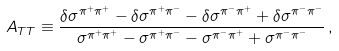Convert formula to latex. <formula><loc_0><loc_0><loc_500><loc_500>A _ { T T } \equiv \frac { \delta \sigma ^ { \pi ^ { + } \pi ^ { + } } - \delta \sigma ^ { \pi ^ { + } \pi ^ { - } } - \delta \sigma ^ { \pi ^ { - } \pi ^ { + } } + \delta \sigma ^ { \pi ^ { - } \pi ^ { - } } } { \sigma ^ { \pi ^ { + } \pi ^ { + } } - \sigma ^ { \pi ^ { + } \pi ^ { - } } - \sigma ^ { \pi ^ { - } \pi ^ { + } } + \sigma ^ { \pi ^ { - } \pi ^ { - } } } \, ,</formula> 